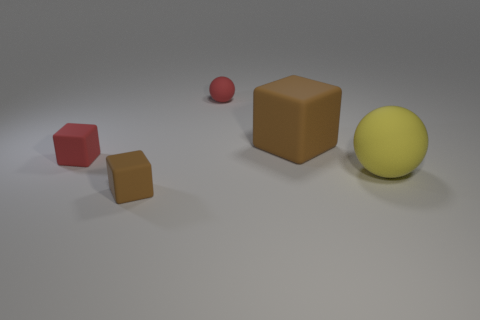What is the material of the yellow thing?
Offer a very short reply. Rubber. The brown thing on the left side of the small red matte sphere has what shape?
Provide a short and direct response. Cube. What color is the other rubber block that is the same size as the red matte block?
Offer a very short reply. Brown. Is the material of the brown cube that is to the right of the red rubber ball the same as the big sphere?
Your answer should be very brief. Yes. How big is the object that is right of the red cube and left of the small matte sphere?
Your response must be concise. Small. What is the size of the red matte object on the right side of the tiny brown rubber object?
Ensure brevity in your answer.  Small. What shape is the matte thing that is the same color as the small sphere?
Provide a succinct answer. Cube. The tiny rubber thing in front of the small red matte thing in front of the brown thing behind the yellow ball is what shape?
Offer a very short reply. Cube. What number of other objects are there of the same shape as the yellow matte object?
Offer a terse response. 1. How many matte things are either yellow things or tiny red cubes?
Provide a short and direct response. 2. 